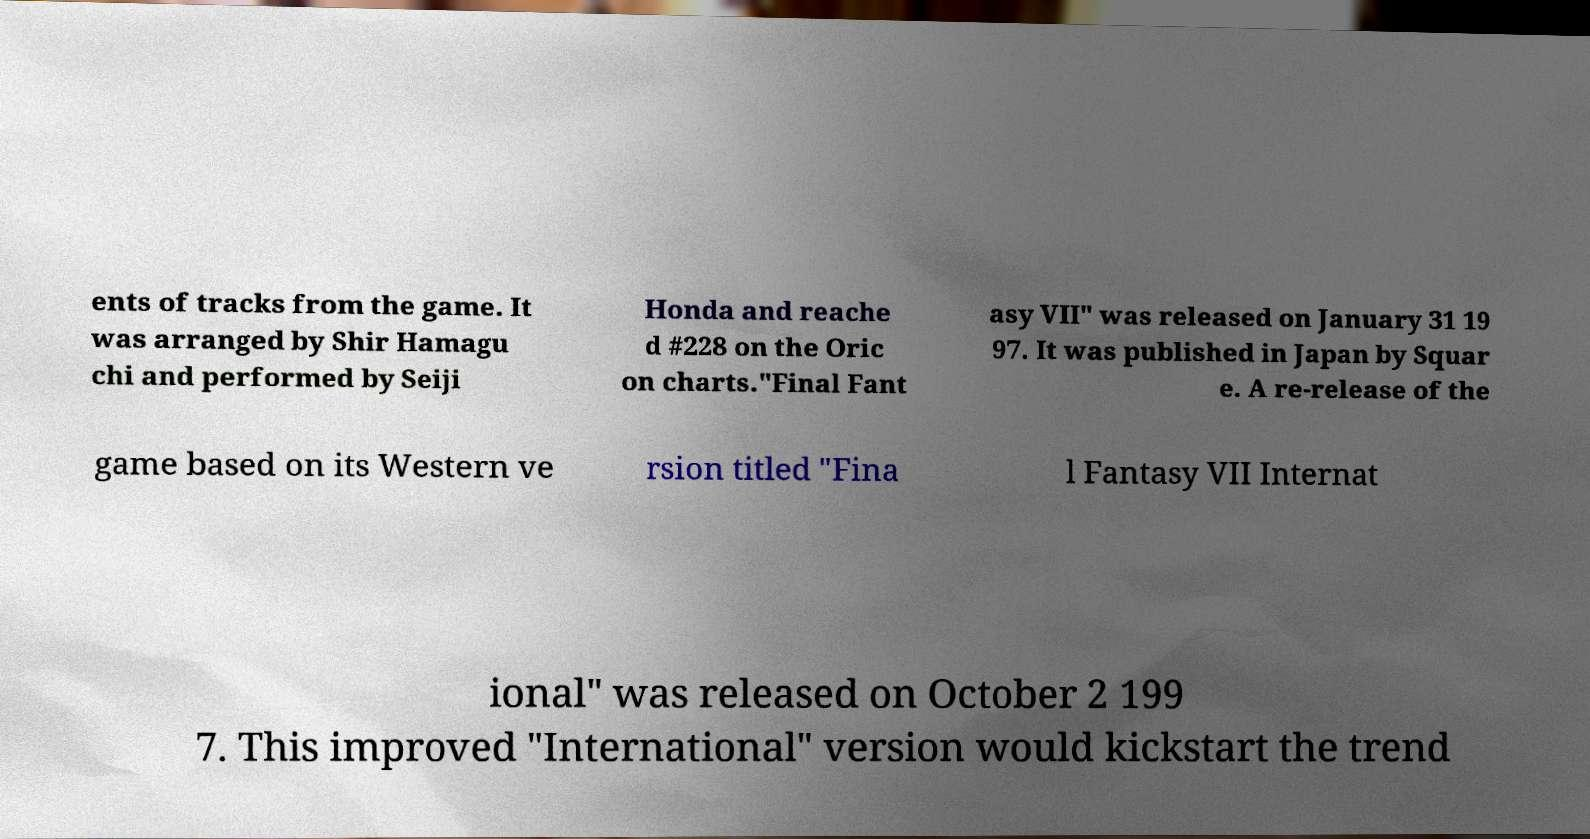Could you extract and type out the text from this image? ents of tracks from the game. It was arranged by Shir Hamagu chi and performed by Seiji Honda and reache d #228 on the Oric on charts."Final Fant asy VII" was released on January 31 19 97. It was published in Japan by Squar e. A re-release of the game based on its Western ve rsion titled "Fina l Fantasy VII Internat ional" was released on October 2 199 7. This improved "International" version would kickstart the trend 